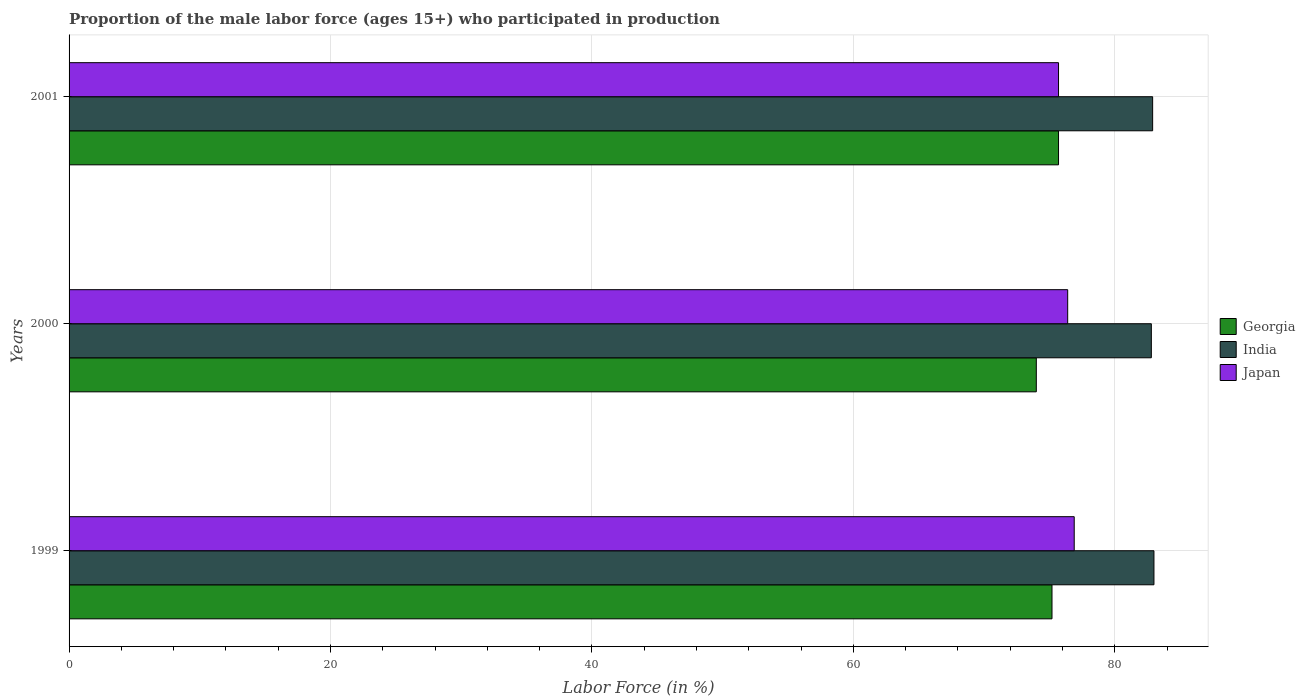How many different coloured bars are there?
Provide a succinct answer. 3. How many groups of bars are there?
Make the answer very short. 3. Are the number of bars per tick equal to the number of legend labels?
Give a very brief answer. Yes. How many bars are there on the 3rd tick from the bottom?
Offer a terse response. 3. What is the label of the 1st group of bars from the top?
Offer a terse response. 2001. In how many cases, is the number of bars for a given year not equal to the number of legend labels?
Provide a succinct answer. 0. What is the proportion of the male labor force who participated in production in India in 1999?
Your response must be concise. 83. Across all years, what is the maximum proportion of the male labor force who participated in production in Japan?
Provide a succinct answer. 76.9. Across all years, what is the minimum proportion of the male labor force who participated in production in Georgia?
Give a very brief answer. 74. What is the total proportion of the male labor force who participated in production in Georgia in the graph?
Keep it short and to the point. 224.9. What is the difference between the proportion of the male labor force who participated in production in Japan in 2000 and that in 2001?
Your answer should be compact. 0.7. What is the difference between the proportion of the male labor force who participated in production in Georgia in 2000 and the proportion of the male labor force who participated in production in India in 1999?
Make the answer very short. -9. What is the average proportion of the male labor force who participated in production in Georgia per year?
Your answer should be compact. 74.97. What is the ratio of the proportion of the male labor force who participated in production in Japan in 1999 to that in 2001?
Your response must be concise. 1.02. Is the difference between the proportion of the male labor force who participated in production in Japan in 2000 and 2001 greater than the difference between the proportion of the male labor force who participated in production in Georgia in 2000 and 2001?
Provide a succinct answer. Yes. What is the difference between the highest and the second highest proportion of the male labor force who participated in production in India?
Your response must be concise. 0.1. What is the difference between the highest and the lowest proportion of the male labor force who participated in production in Georgia?
Make the answer very short. 1.7. In how many years, is the proportion of the male labor force who participated in production in Georgia greater than the average proportion of the male labor force who participated in production in Georgia taken over all years?
Provide a succinct answer. 2. Is the sum of the proportion of the male labor force who participated in production in Georgia in 2000 and 2001 greater than the maximum proportion of the male labor force who participated in production in Japan across all years?
Ensure brevity in your answer.  Yes. What does the 2nd bar from the top in 2001 represents?
Provide a succinct answer. India. What does the 3rd bar from the bottom in 1999 represents?
Keep it short and to the point. Japan. Is it the case that in every year, the sum of the proportion of the male labor force who participated in production in Japan and proportion of the male labor force who participated in production in Georgia is greater than the proportion of the male labor force who participated in production in India?
Give a very brief answer. Yes. How many bars are there?
Your answer should be compact. 9. What is the difference between two consecutive major ticks on the X-axis?
Give a very brief answer. 20. Are the values on the major ticks of X-axis written in scientific E-notation?
Keep it short and to the point. No. Where does the legend appear in the graph?
Provide a succinct answer. Center right. How many legend labels are there?
Give a very brief answer. 3. What is the title of the graph?
Make the answer very short. Proportion of the male labor force (ages 15+) who participated in production. Does "India" appear as one of the legend labels in the graph?
Give a very brief answer. Yes. What is the label or title of the Y-axis?
Keep it short and to the point. Years. What is the Labor Force (in %) of Georgia in 1999?
Ensure brevity in your answer.  75.2. What is the Labor Force (in %) in India in 1999?
Your answer should be very brief. 83. What is the Labor Force (in %) in Japan in 1999?
Keep it short and to the point. 76.9. What is the Labor Force (in %) of India in 2000?
Provide a succinct answer. 82.8. What is the Labor Force (in %) in Japan in 2000?
Offer a terse response. 76.4. What is the Labor Force (in %) of Georgia in 2001?
Ensure brevity in your answer.  75.7. What is the Labor Force (in %) of India in 2001?
Your response must be concise. 82.9. What is the Labor Force (in %) in Japan in 2001?
Provide a succinct answer. 75.7. Across all years, what is the maximum Labor Force (in %) in Georgia?
Give a very brief answer. 75.7. Across all years, what is the maximum Labor Force (in %) of Japan?
Give a very brief answer. 76.9. Across all years, what is the minimum Labor Force (in %) in India?
Ensure brevity in your answer.  82.8. Across all years, what is the minimum Labor Force (in %) in Japan?
Provide a short and direct response. 75.7. What is the total Labor Force (in %) of Georgia in the graph?
Keep it short and to the point. 224.9. What is the total Labor Force (in %) in India in the graph?
Ensure brevity in your answer.  248.7. What is the total Labor Force (in %) of Japan in the graph?
Provide a succinct answer. 229. What is the difference between the Labor Force (in %) of Georgia in 1999 and that in 2000?
Your response must be concise. 1.2. What is the difference between the Labor Force (in %) in India in 1999 and that in 2000?
Make the answer very short. 0.2. What is the difference between the Labor Force (in %) of India in 1999 and that in 2001?
Offer a terse response. 0.1. What is the difference between the Labor Force (in %) of Georgia in 2000 and that in 2001?
Give a very brief answer. -1.7. What is the difference between the Labor Force (in %) of India in 2000 and that in 2001?
Your answer should be compact. -0.1. What is the difference between the Labor Force (in %) in Georgia in 1999 and the Labor Force (in %) in Japan in 2000?
Make the answer very short. -1.2. What is the difference between the Labor Force (in %) in India in 1999 and the Labor Force (in %) in Japan in 2000?
Provide a succinct answer. 6.6. What is the difference between the Labor Force (in %) of Georgia in 1999 and the Labor Force (in %) of Japan in 2001?
Keep it short and to the point. -0.5. What is the difference between the Labor Force (in %) of Georgia in 2000 and the Labor Force (in %) of Japan in 2001?
Your answer should be very brief. -1.7. What is the average Labor Force (in %) in Georgia per year?
Your answer should be compact. 74.97. What is the average Labor Force (in %) in India per year?
Your answer should be very brief. 82.9. What is the average Labor Force (in %) in Japan per year?
Provide a succinct answer. 76.33. In the year 1999, what is the difference between the Labor Force (in %) of Georgia and Labor Force (in %) of India?
Provide a short and direct response. -7.8. In the year 1999, what is the difference between the Labor Force (in %) of Georgia and Labor Force (in %) of Japan?
Your response must be concise. -1.7. In the year 1999, what is the difference between the Labor Force (in %) in India and Labor Force (in %) in Japan?
Offer a very short reply. 6.1. In the year 2000, what is the difference between the Labor Force (in %) of Georgia and Labor Force (in %) of India?
Provide a succinct answer. -8.8. In the year 2000, what is the difference between the Labor Force (in %) in Georgia and Labor Force (in %) in Japan?
Offer a terse response. -2.4. In the year 2001, what is the difference between the Labor Force (in %) in Georgia and Labor Force (in %) in India?
Ensure brevity in your answer.  -7.2. In the year 2001, what is the difference between the Labor Force (in %) of Georgia and Labor Force (in %) of Japan?
Offer a very short reply. 0. In the year 2001, what is the difference between the Labor Force (in %) of India and Labor Force (in %) of Japan?
Give a very brief answer. 7.2. What is the ratio of the Labor Force (in %) of Georgia in 1999 to that in 2000?
Your answer should be very brief. 1.02. What is the ratio of the Labor Force (in %) in India in 1999 to that in 2001?
Give a very brief answer. 1. What is the ratio of the Labor Force (in %) in Japan in 1999 to that in 2001?
Offer a terse response. 1.02. What is the ratio of the Labor Force (in %) in Georgia in 2000 to that in 2001?
Offer a very short reply. 0.98. What is the ratio of the Labor Force (in %) in India in 2000 to that in 2001?
Give a very brief answer. 1. What is the ratio of the Labor Force (in %) of Japan in 2000 to that in 2001?
Make the answer very short. 1.01. What is the difference between the highest and the second highest Labor Force (in %) in Georgia?
Give a very brief answer. 0.5. What is the difference between the highest and the second highest Labor Force (in %) of Japan?
Offer a very short reply. 0.5. What is the difference between the highest and the lowest Labor Force (in %) in India?
Ensure brevity in your answer.  0.2. What is the difference between the highest and the lowest Labor Force (in %) in Japan?
Provide a succinct answer. 1.2. 